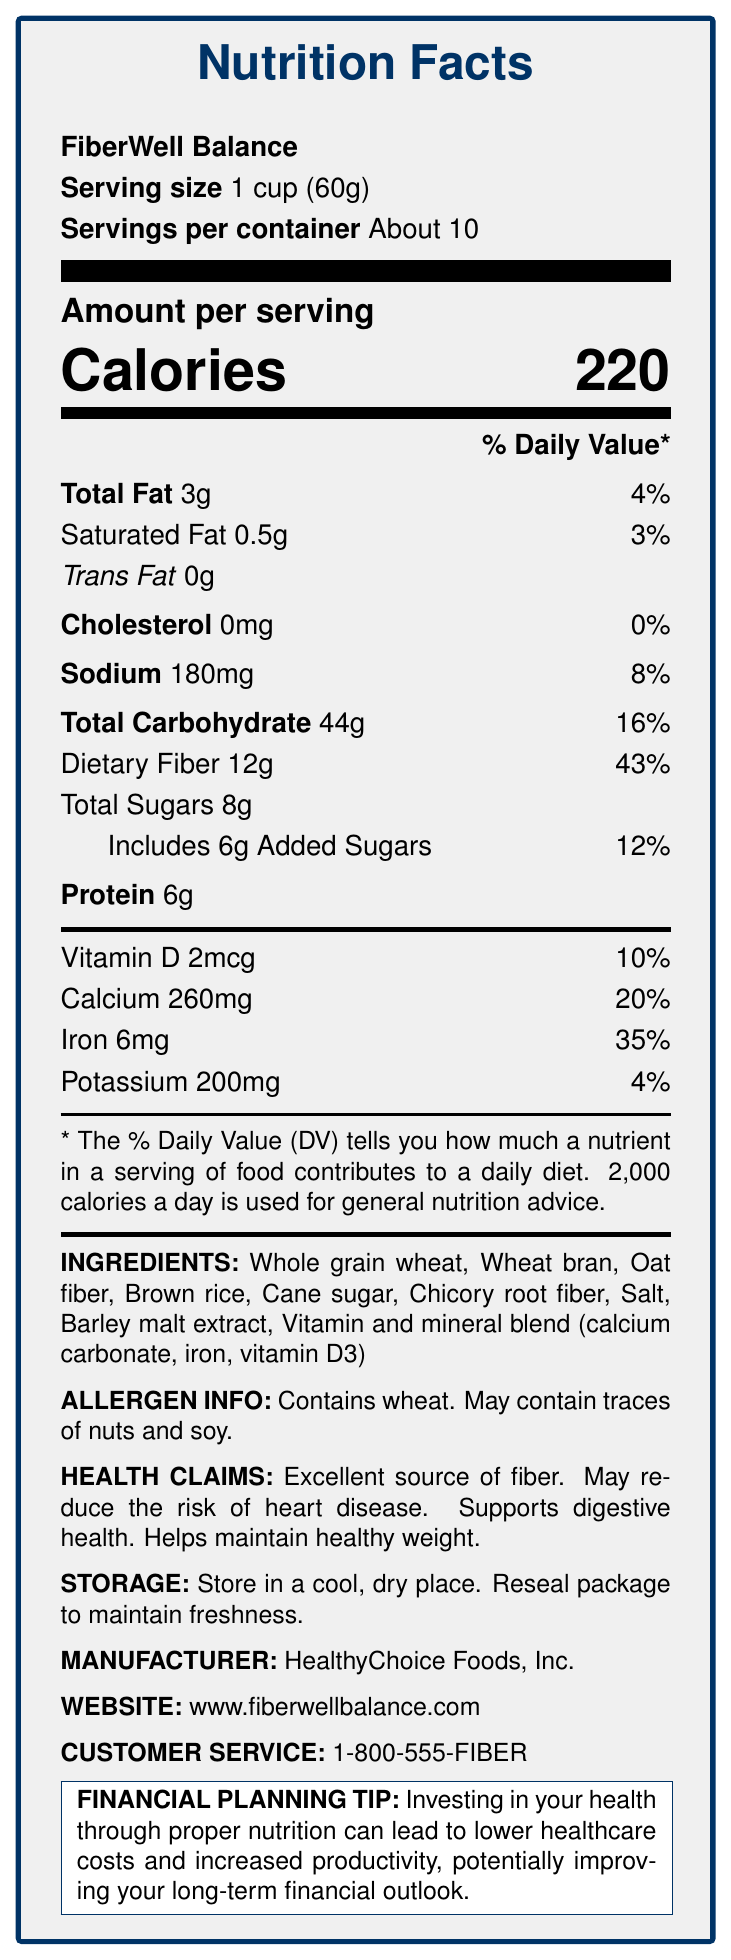what is the product name? The product name is clearly stated at the beginning of the document under the "Nutrition Facts" title.
Answer: FiberWell Balance What is the serving size of FiberWell Balance? The serving size is listed right after the product name as “Serving size 1 cup (60g)”.
Answer: 1 cup (60g) How many calories are in one serving of FiberWell Balance? The nutrient information section under "Amount per serving" lists the calories as 220.
Answer: 220 How much dietary fiber is in a serving, and what is its % daily value? The document shows "Dietary Fiber 12g" and "43%" next to it in the nutrient details.
Answer: 12g, 43% What are the main ingredients of FiberWell Balance? The ingredients section lists these items explicitly.
Answer: Whole grain wheat, Wheat bran, Oat fiber, Brown rice, Cane sugar, Chicory root fiber, Salt, Barley malt extract, Vitamin and mineral blend (calcium carbonate, iron, vitamin D3) Which company manufactures FiberWell Balance? (Multiple Choice) 
A. HealthyChoice Foods, Inc.
B. NutriHealth Inc.
C. FiberFoods Co.
D. BalancedHealth Ltd. The document specifies "HealthyChoice Foods, Inc." as the manufacturer under the "Manufacturer" section.
Answer: A How much calcium does one serving provide? 
1. 10%
2. 20%
3. 35%
4. 40% The document lists "Calcium 260mg" with a daily value of "20%" in the nutrient details.
Answer: 2 Does FiberWell Balance contain any trans fat? The document explicitly states "Trans Fat 0g" under the total fat information.
Answer: No Is Vitamin D present in FiberWell Balance? The nutrient details mention "Vitamin D 2mcg" with a 10% daily value.
Answer: Yes Summarize the main purpose of the document. This inclusive summary describes all the sections of the document including nutritional facts, ingredients, health claims, storage instructions, and additional practical information.
Answer: The document provides detailed nutritional information about FiberWell Balance cereal, highlighting its health benefits, ingredients, allergen information, and storage instructions. It emphasizes the cereal's high fiber content and related health claims while also providing manufacturer details and a financial planning tip related to health investment. How much sugar in total does a serving of FiberWell Balance contain? The document lists "Total Sugars 8g" under the total carbohydrate details.
Answer: 8g What claim is made about FiberWell Balance regarding heart disease? The section on health claims includes "May reduce the risk of heart disease" as one of the benefits.
Answer: May reduce the risk of heart disease What is the customer service number for FiberWell Balance? The document lists the customer service number near the end under the "Customer Service" section.
Answer: 1-800-555-FIBER What is the daily value percentage for sodium in a serving? The nutrient details mention "Sodium 180mg" with a daily value of "8%".
Answer: 8% Does the document provide any information on the price of FiberWell Balance? The document does not mention the price of FiberWell Balance cereal.
Answer: Not enough information What should you do to maintain the freshness of FiberWell Balance? The storage instructions indicate these steps explicitly to keep the product fresh.
Answer: Store in a cool, dry place. Reseal package to maintain freshness. 